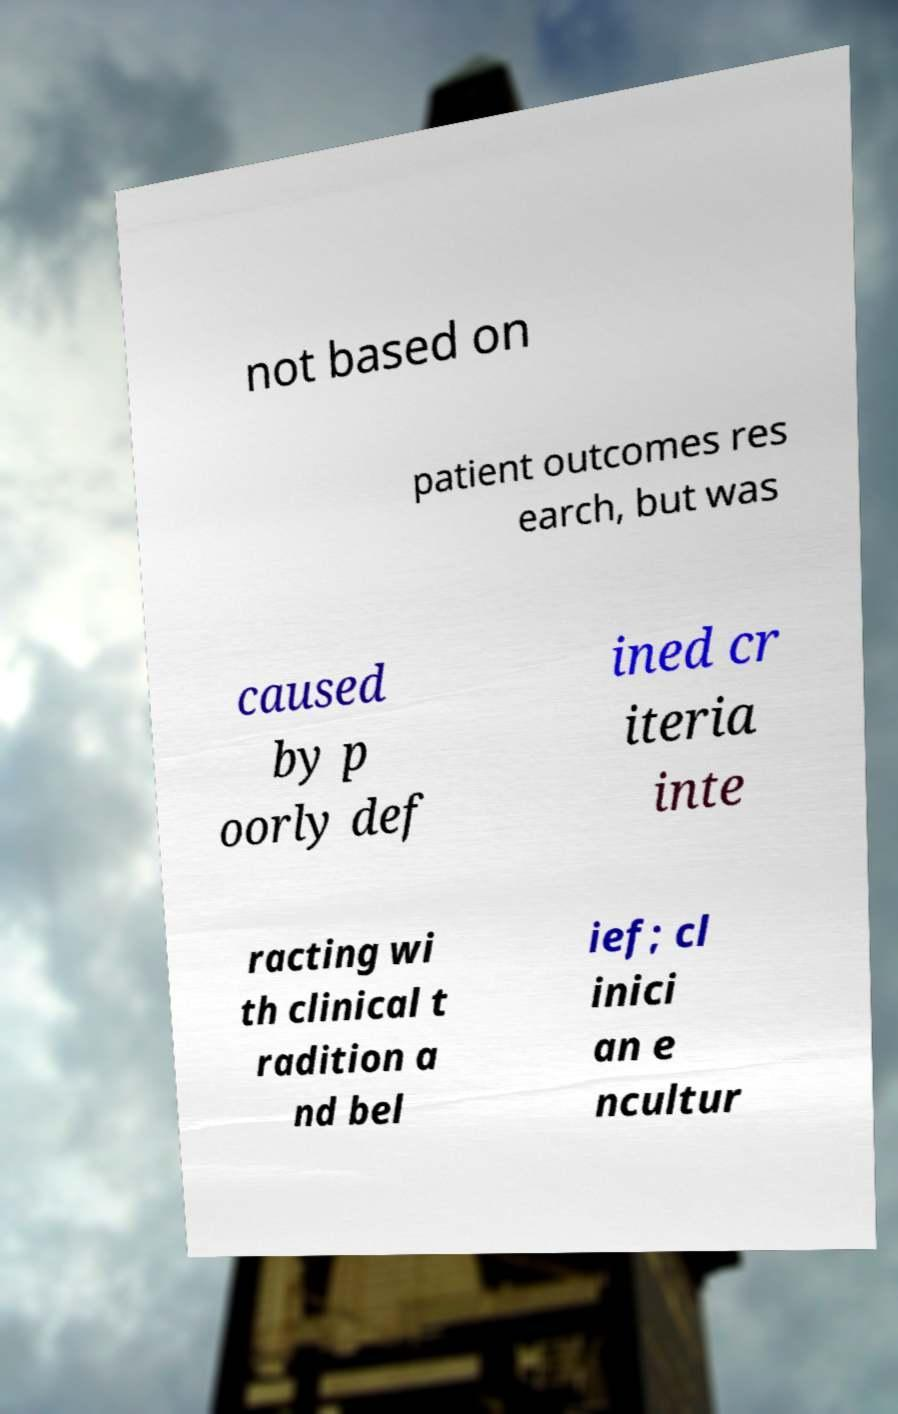Could you extract and type out the text from this image? not based on patient outcomes res earch, but was caused by p oorly def ined cr iteria inte racting wi th clinical t radition a nd bel ief; cl inici an e ncultur 